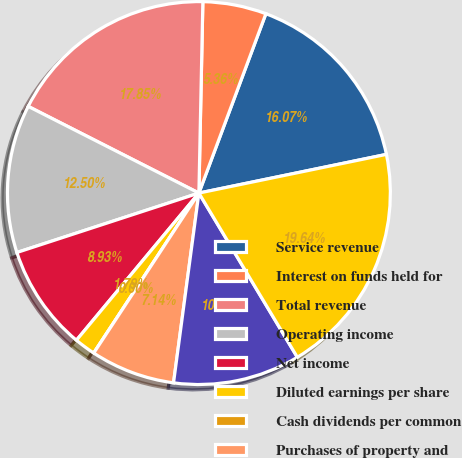Convert chart. <chart><loc_0><loc_0><loc_500><loc_500><pie_chart><fcel>Service revenue<fcel>Interest on funds held for<fcel>Total revenue<fcel>Operating income<fcel>Net income<fcel>Diluted earnings per share<fcel>Cash dividends per common<fcel>Purchases of property and<fcel>Cash and total corporate<fcel>Total assets<nl><fcel>16.07%<fcel>5.36%<fcel>17.85%<fcel>12.5%<fcel>8.93%<fcel>1.79%<fcel>0.0%<fcel>7.14%<fcel>10.71%<fcel>19.64%<nl></chart> 